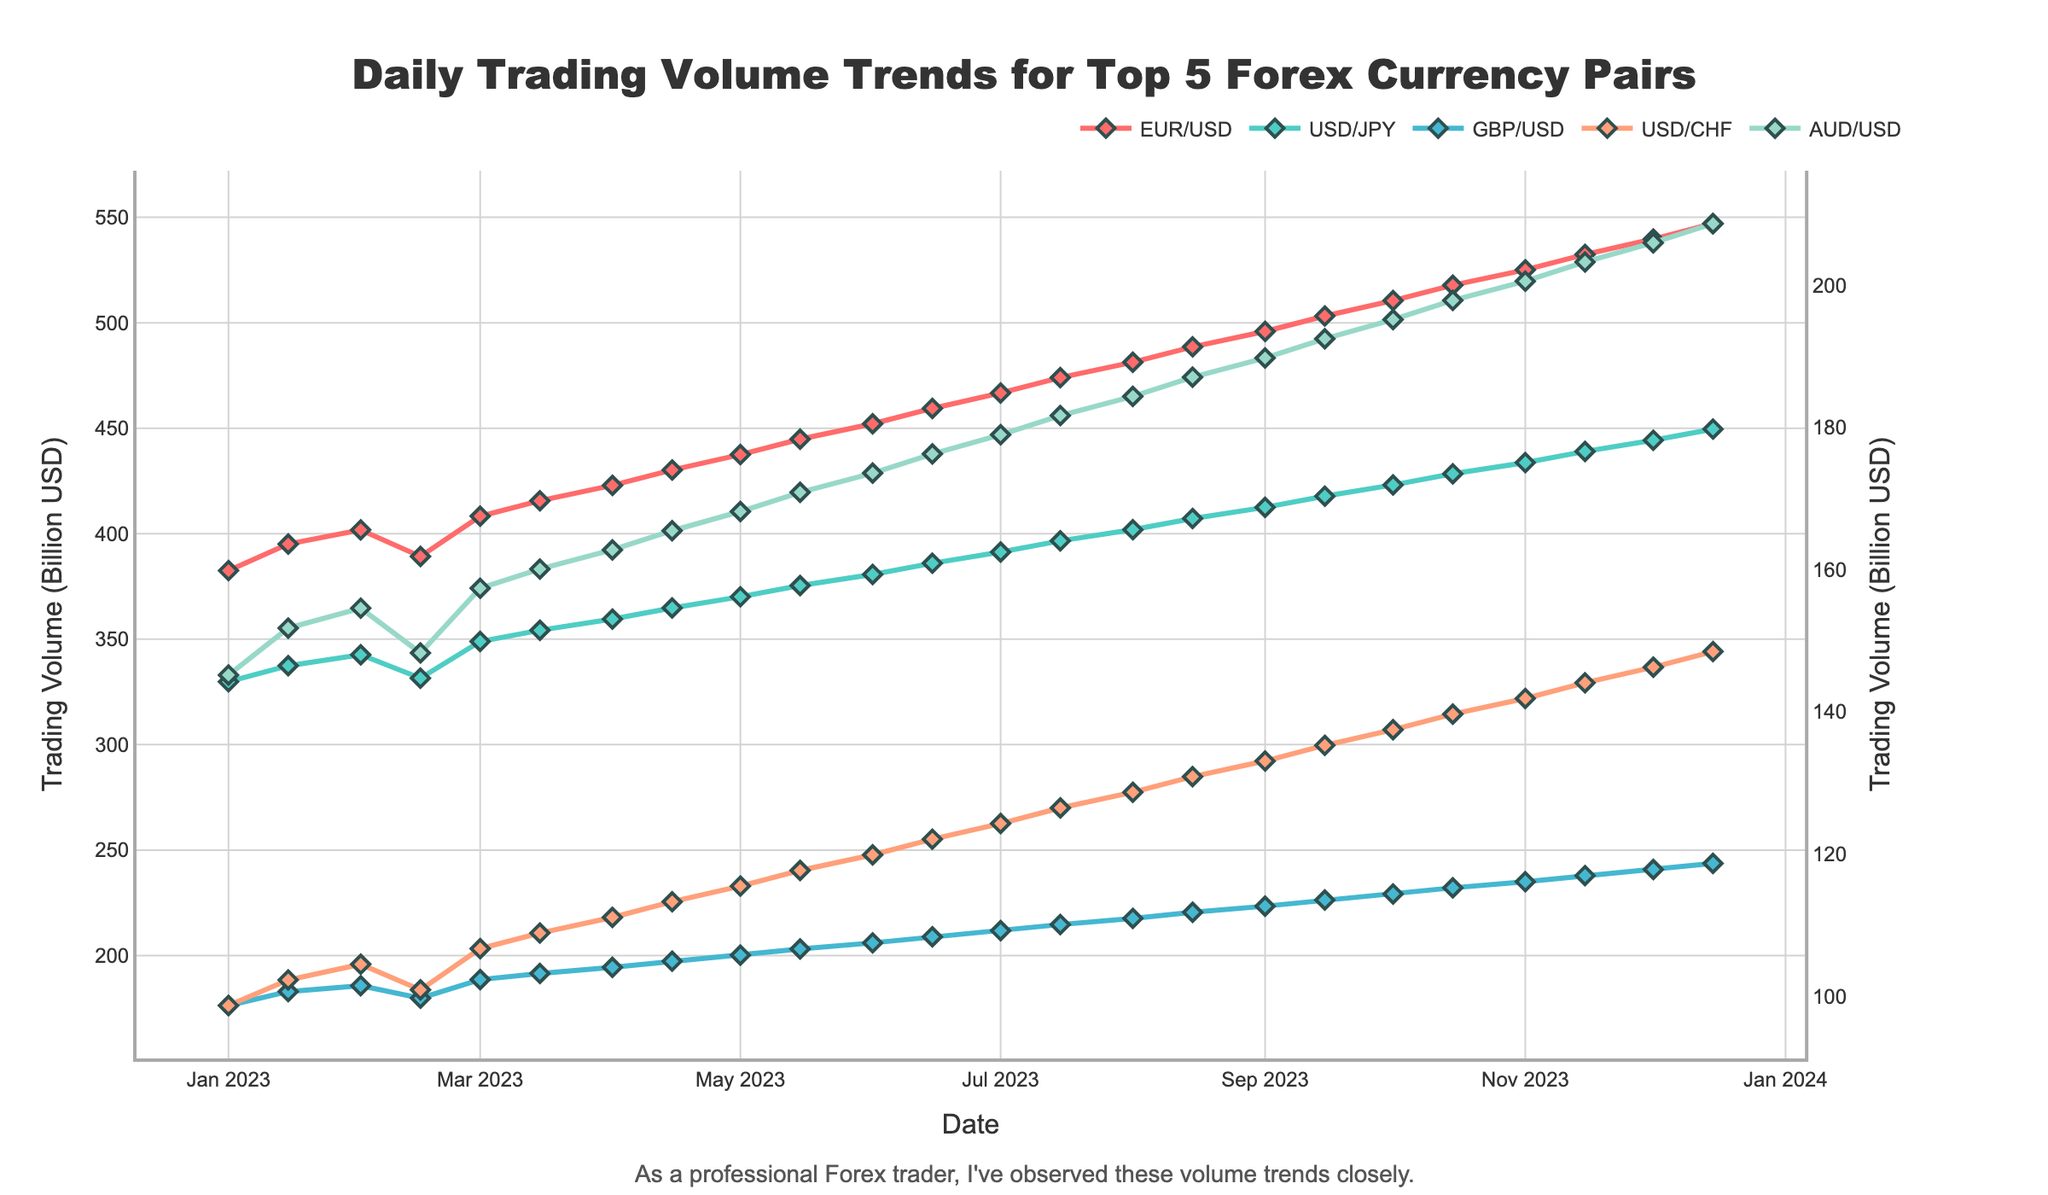Which currency pair has the highest daily trading volume on 2023-12-15? To find the highest daily trading volume on 2023-12-15, look at the values plotted on that date for each currency pair. The tallest marker on 2023-12-15 represents the currency pair with the highest trading volume. In this case, it is EUR/USD.
Answer: EUR/USD How does the trading volume of USD/JPY on 2023-06-01 compare to that on 2023-06-15? Look at the points for USD/JPY (colored differently) on 2023-06-01 and 2023-06-15. Compare their heights to determine the difference. The volume increases from 380.7 on 2023-06-01 to 386.0 on 2023-06-15.
Answer: It increased What is the average trading volume for AUD/USD over the first quarter of 2023? Calculate the mean of AUD/USD volumes on 2023-01-01, 2023-01-15, 2023-02-01, 2023-02-15, and 2023-03-01. Sum these values (145.2 + 151.8 + 154.6 + 148.3 + 157.4) and divide by 5: (145.2 + 151.8 + 154.6 + 148.3 + 157.4) / 5 = 151.46.
Answer: 151.46 Identify the currency pair with the most volatile trading volume changes in 2023. Evaluate the variations in each currency pair’s trading volume over the entire year by seeing the amplitude of the lines for each. The currency pair with the most noticeable fluctuations is most volatile. From the plot, EUR/USD shows the highest fluctuation.
Answer: EUR/USD Compare the trend lines of GBP/USD and USD/CHF throughout 2023. Which pair shows a steeper increase? To identify the steeper trend, compare the slopes of the lines for GBP/USD and USD/CHF across the months. The line that ascends more quickly shows a steeper increase. By the end of the year, GBP/USD shows a steeper increasing trend than USD/CHF.
Answer: GBP/USD Calculate the sum of trading volumes for EUR/USD and USD/JPY on 2023-05-01. Add the individual trading volumes of EUR/USD and USD/JPY on 2023-05-01. (437.5 for EUR/USD and 370.1 for USD/JPY). The sum is 437.5 + 370.1 = 807.6.
Answer: 807.6 Did any currency pair have a declining trend in trading volume throughout the year? Inspect each line graph’s slope to determine if any are consistently decreasing. None of the currency pairs show a declining trend; all exhibit upward or fluctuating patterns.
Answer: No 